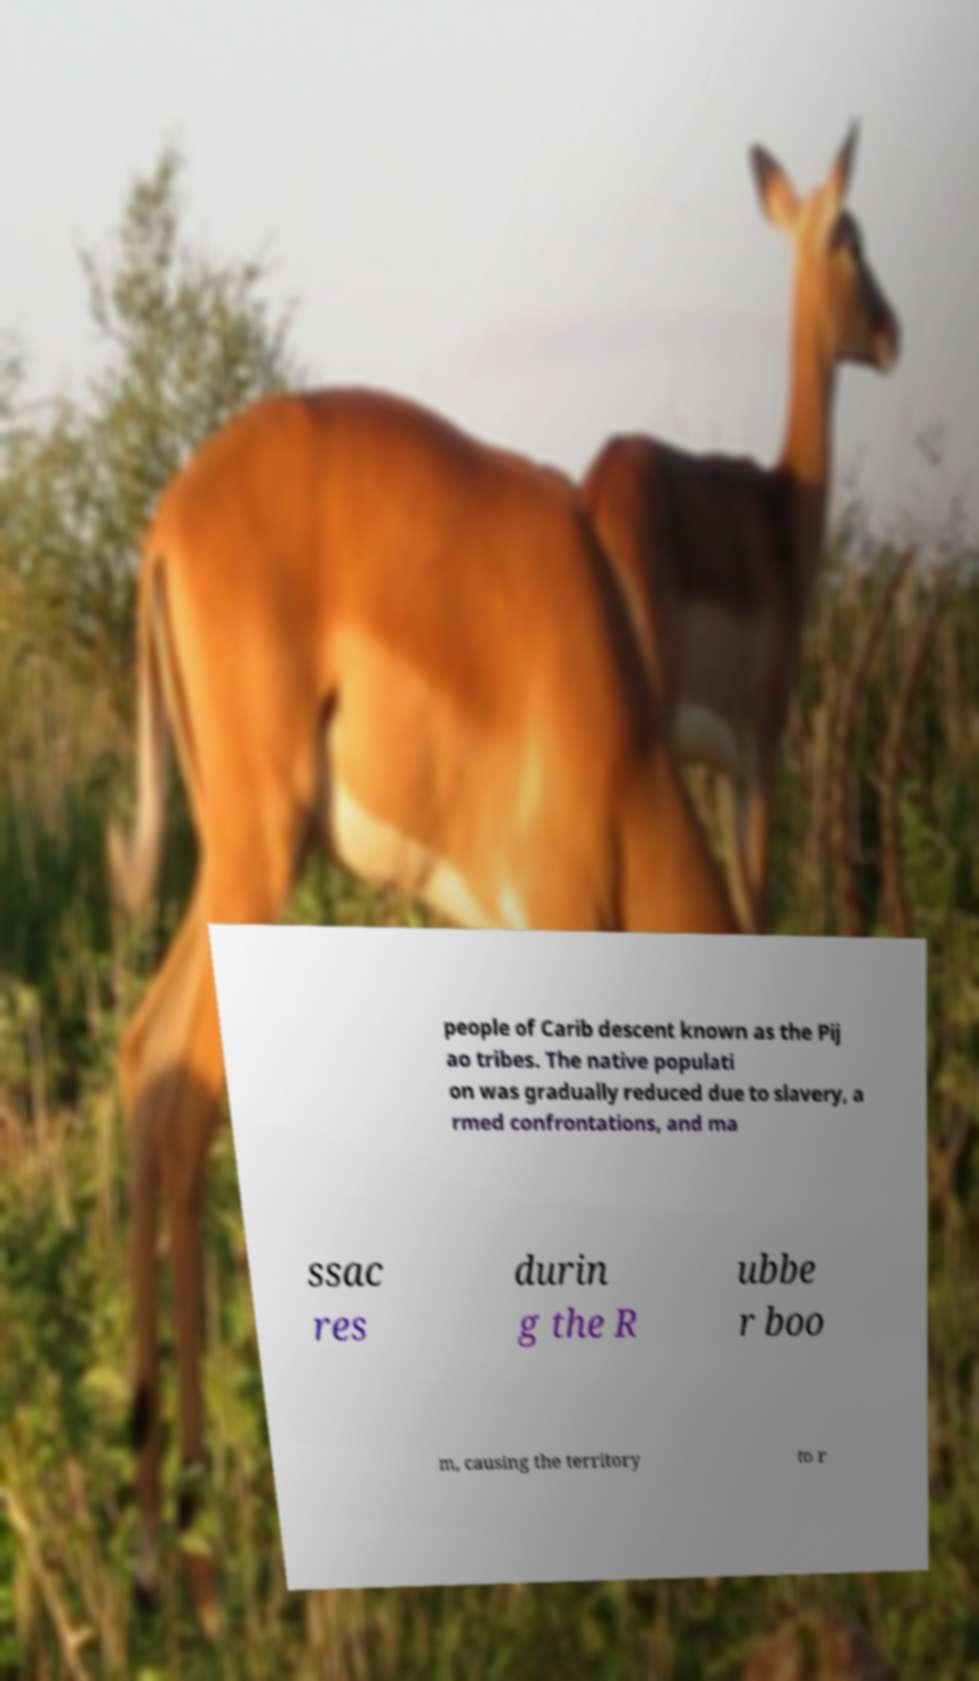I need the written content from this picture converted into text. Can you do that? people of Carib descent known as the Pij ao tribes. The native populati on was gradually reduced due to slavery, a rmed confrontations, and ma ssac res durin g the R ubbe r boo m, causing the territory to r 